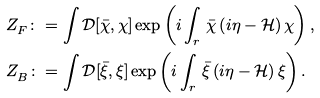Convert formula to latex. <formula><loc_0><loc_0><loc_500><loc_500>& Z ^ { \ } _ { F } \colon = \int \mathcal { D } [ \bar { \chi } , \chi ] \exp \left ( { i } \int _ { r } \, \bar { \chi } \left ( { i } \eta - \mathcal { H } \right ) \chi \right ) , \\ & Z ^ { \ } _ { B } \colon = \int \mathcal { D } [ \bar { \xi } , \xi ] \exp \left ( { i } \int _ { r } \, \bar { \xi } \left ( { i } \eta - \mathcal { H } \right ) \xi \right ) .</formula> 